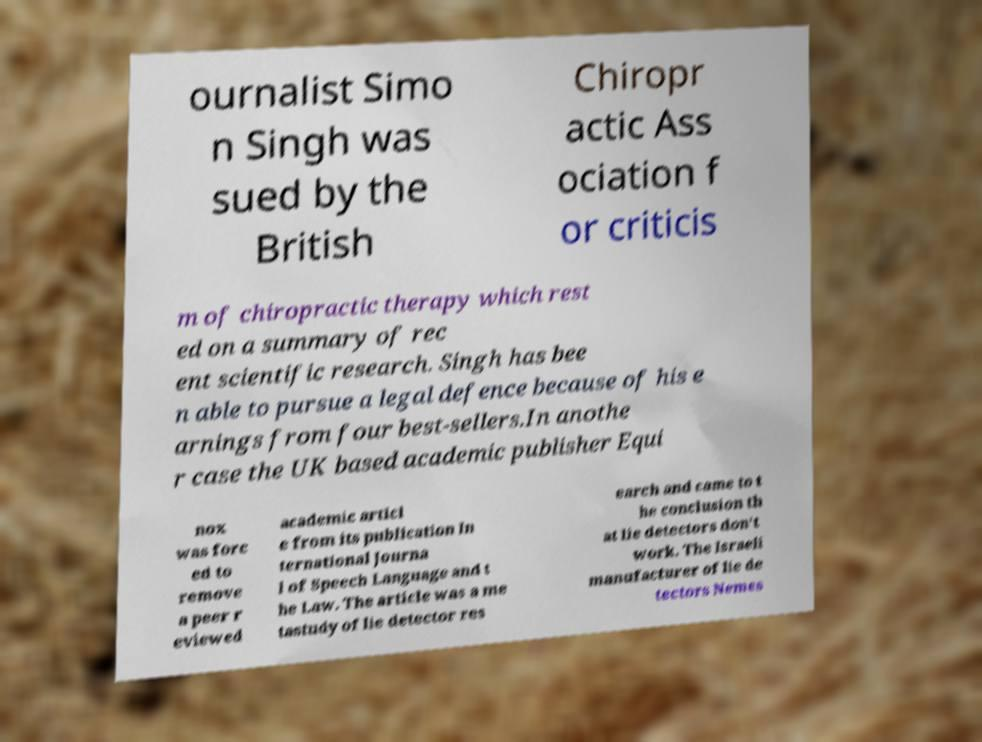Could you assist in decoding the text presented in this image and type it out clearly? ournalist Simo n Singh was sued by the British Chiropr actic Ass ociation f or criticis m of chiropractic therapy which rest ed on a summary of rec ent scientific research. Singh has bee n able to pursue a legal defence because of his e arnings from four best-sellers.In anothe r case the UK based academic publisher Equi nox was forc ed to remove a peer r eviewed academic articl e from its publication In ternational Journa l of Speech Language and t he Law. The article was a me tastudy of lie detector res earch and came to t he conclusion th at lie detectors don't work. The Israeli manufacturer of lie de tectors Nemes 